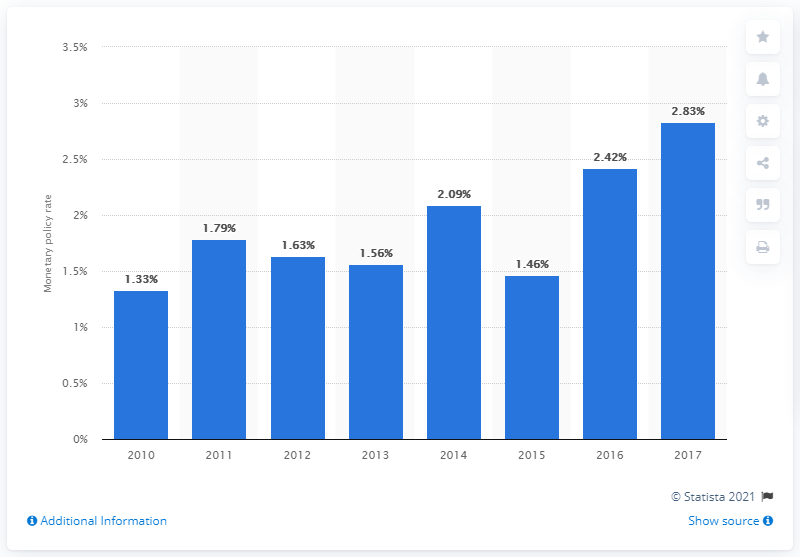Point out several critical features in this image. In 2017, the monetary policy rate in El Salvador was 2.83%. 